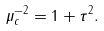Convert formula to latex. <formula><loc_0><loc_0><loc_500><loc_500>\mu _ { c } ^ { - 2 } = 1 + \tau ^ { 2 } .</formula> 